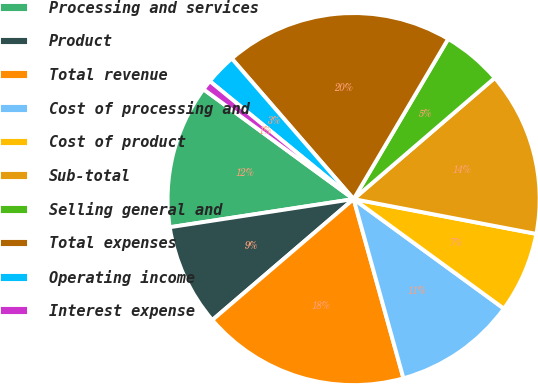Convert chart. <chart><loc_0><loc_0><loc_500><loc_500><pie_chart><fcel>Processing and services<fcel>Product<fcel>Total revenue<fcel>Cost of processing and<fcel>Cost of product<fcel>Sub-total<fcel>Selling general and<fcel>Total expenses<fcel>Operating income<fcel>Interest expense<nl><fcel>12.47%<fcel>8.85%<fcel>18.05%<fcel>10.66%<fcel>7.03%<fcel>14.29%<fcel>5.22%<fcel>19.86%<fcel>2.7%<fcel>0.88%<nl></chart> 